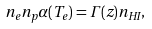<formula> <loc_0><loc_0><loc_500><loc_500>n _ { e } n _ { p } \alpha ( T _ { e } ) = \Gamma ( z ) n _ { H I } ,</formula> 